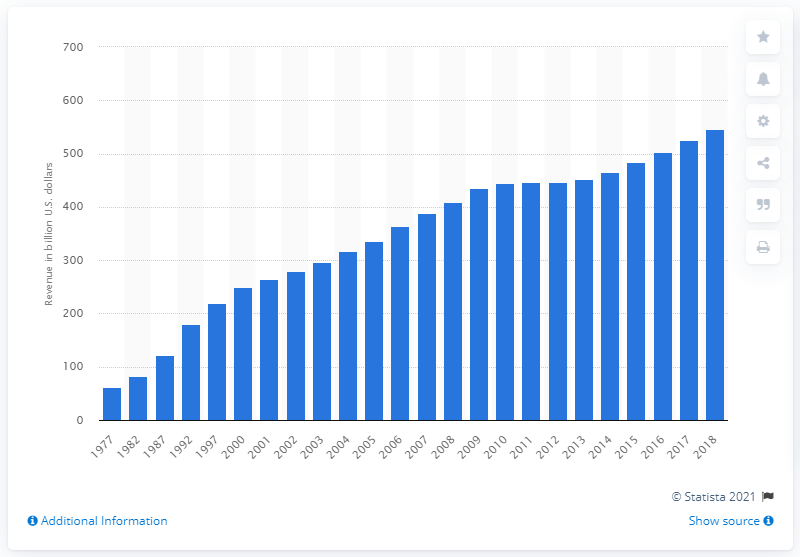Identify some key points in this picture. In 2018, state and local governments collected a total of $547.04 million through property taxes. 